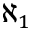Convert formula to latex. <formula><loc_0><loc_0><loc_500><loc_500>\aleph _ { 1 }</formula> 